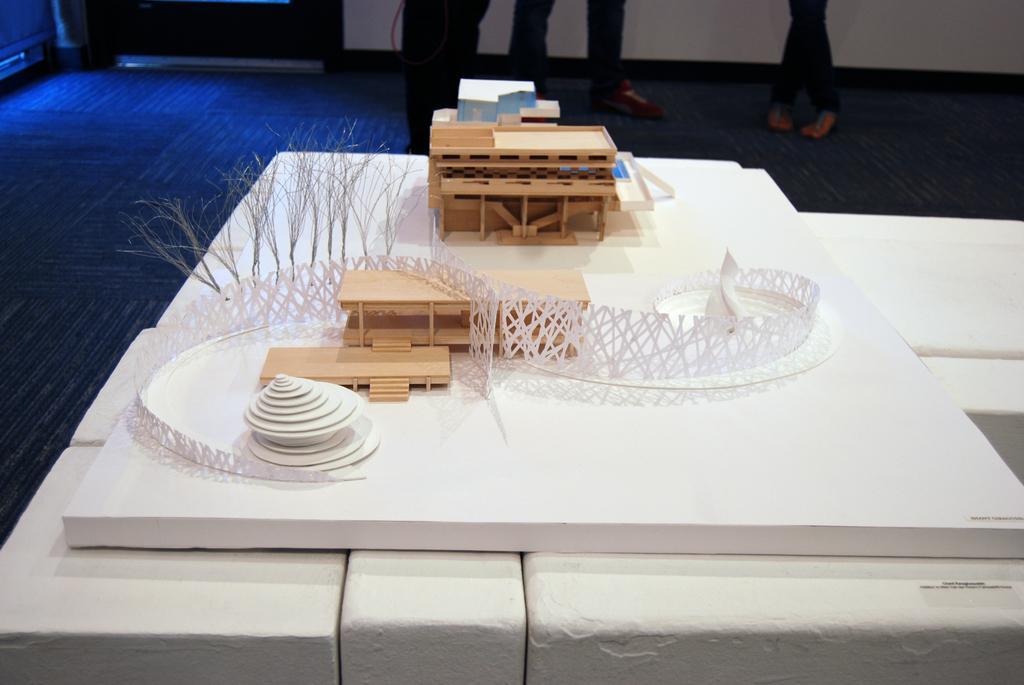Please provide a concise description of this image. In this picture, there is a miniature art placed on the table. In the miniature art, there are buildings, trees and bridge are made. On the top there are people, only can be seen. Towards the left, there is a mat which is in blue in color. 